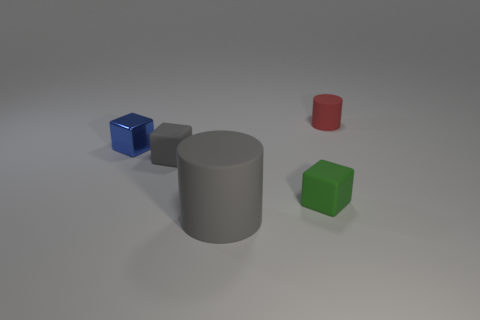Add 5 small cyan matte cylinders. How many objects exist? 10 Subtract all cubes. How many objects are left? 2 Add 3 green blocks. How many green blocks exist? 4 Subtract 1 red cylinders. How many objects are left? 4 Subtract all small green matte blocks. Subtract all big yellow metal objects. How many objects are left? 4 Add 1 metallic cubes. How many metallic cubes are left? 2 